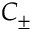Convert formula to latex. <formula><loc_0><loc_0><loc_500><loc_500>C _ { \pm }</formula> 